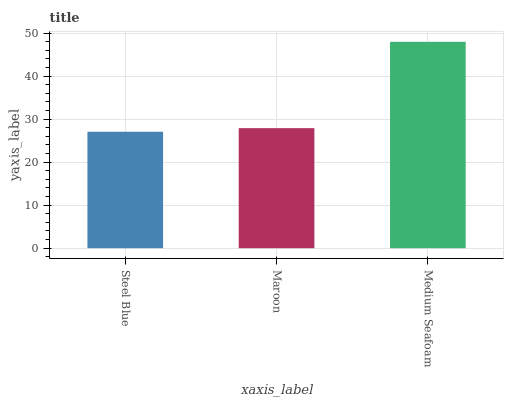Is Maroon the minimum?
Answer yes or no. No. Is Maroon the maximum?
Answer yes or no. No. Is Maroon greater than Steel Blue?
Answer yes or no. Yes. Is Steel Blue less than Maroon?
Answer yes or no. Yes. Is Steel Blue greater than Maroon?
Answer yes or no. No. Is Maroon less than Steel Blue?
Answer yes or no. No. Is Maroon the high median?
Answer yes or no. Yes. Is Maroon the low median?
Answer yes or no. Yes. Is Medium Seafoam the high median?
Answer yes or no. No. Is Medium Seafoam the low median?
Answer yes or no. No. 